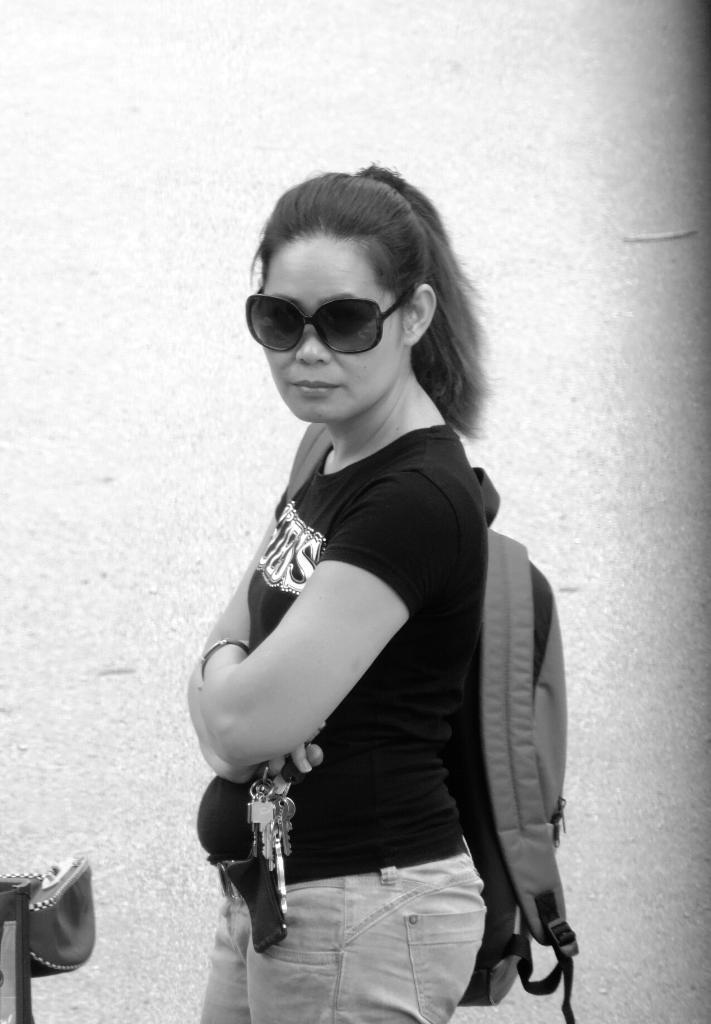What is the color scheme of the image? The image is black and white. Who is present in the image? There is a woman in the image. What is the woman doing in the image? The woman is standing. What is the woman wearing in the image? The woman is wearing a bag. What is the woman holding in the image? The woman is holding keys. What can be seen on the left side of the image? There is an object on the left side of the image. What is the woman's voice like in the image? There is no audio in the image, so we cannot determine the woman's voice. How many sides does the object on the left side of the image have? The provided facts do not mention the number of sides of the object on the left side of the image. 